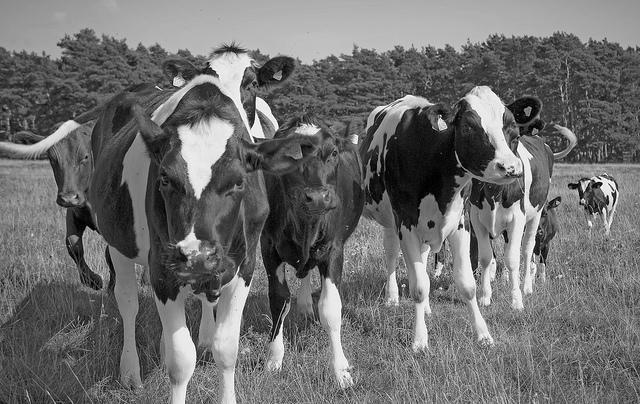How many cows are there?
Give a very brief answer. 8. How many cows are in the photo?
Give a very brief answer. 6. How many orange pillows in the image?
Give a very brief answer. 0. 